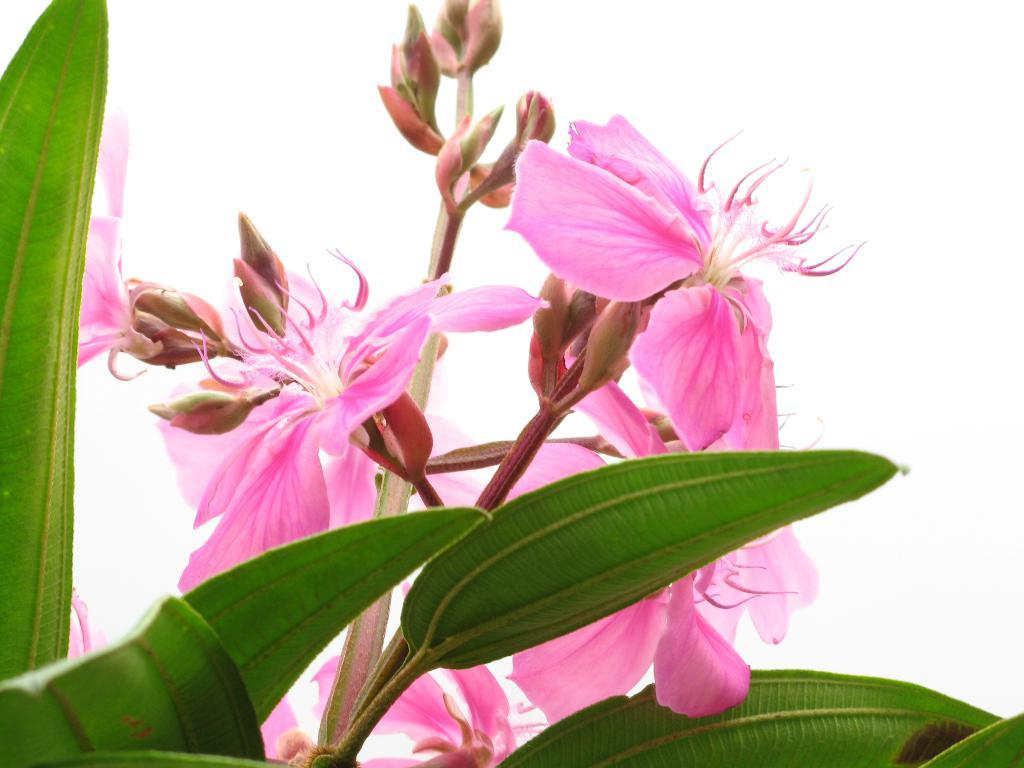What type of plants can be seen in the image? There are flowers and leaves in the image. Can you describe the appearance of the flowers? Unfortunately, the specific appearance of the flowers cannot be determined from the provided facts. What else is present in the image besides flowers and leaves? The provided facts only mention flowers and leaves, so there is no additional information about other elements in the image. What type of credit card is visible in the image? There is no credit card present in the image; it only features flowers and leaves. Can you tell me how many socks are shown in the image? There are no socks present in the image; it only features flowers and leaves. 